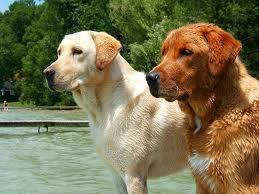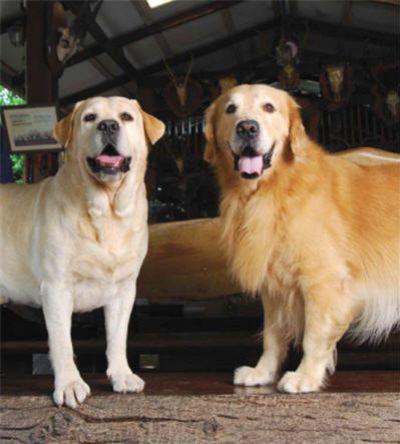The first image is the image on the left, the second image is the image on the right. Evaluate the accuracy of this statement regarding the images: "There are three labs posing together in each image.". Is it true? Answer yes or no. No. 